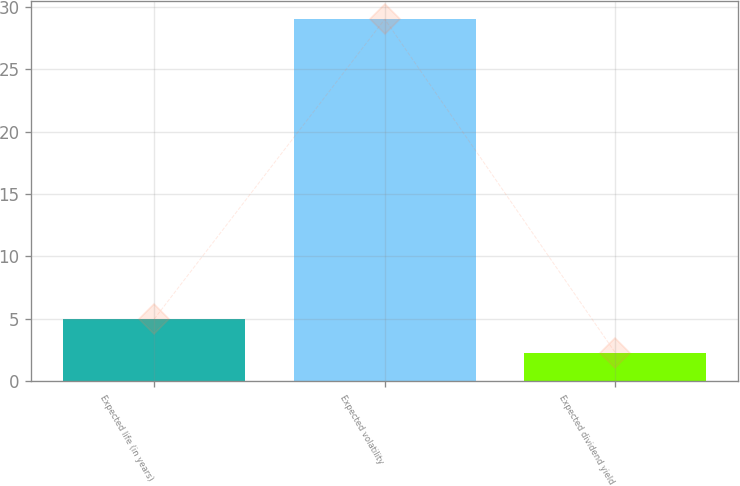<chart> <loc_0><loc_0><loc_500><loc_500><bar_chart><fcel>Expected life (in years)<fcel>Expected volatility<fcel>Expected dividend yield<nl><fcel>5<fcel>29<fcel>2.3<nl></chart> 